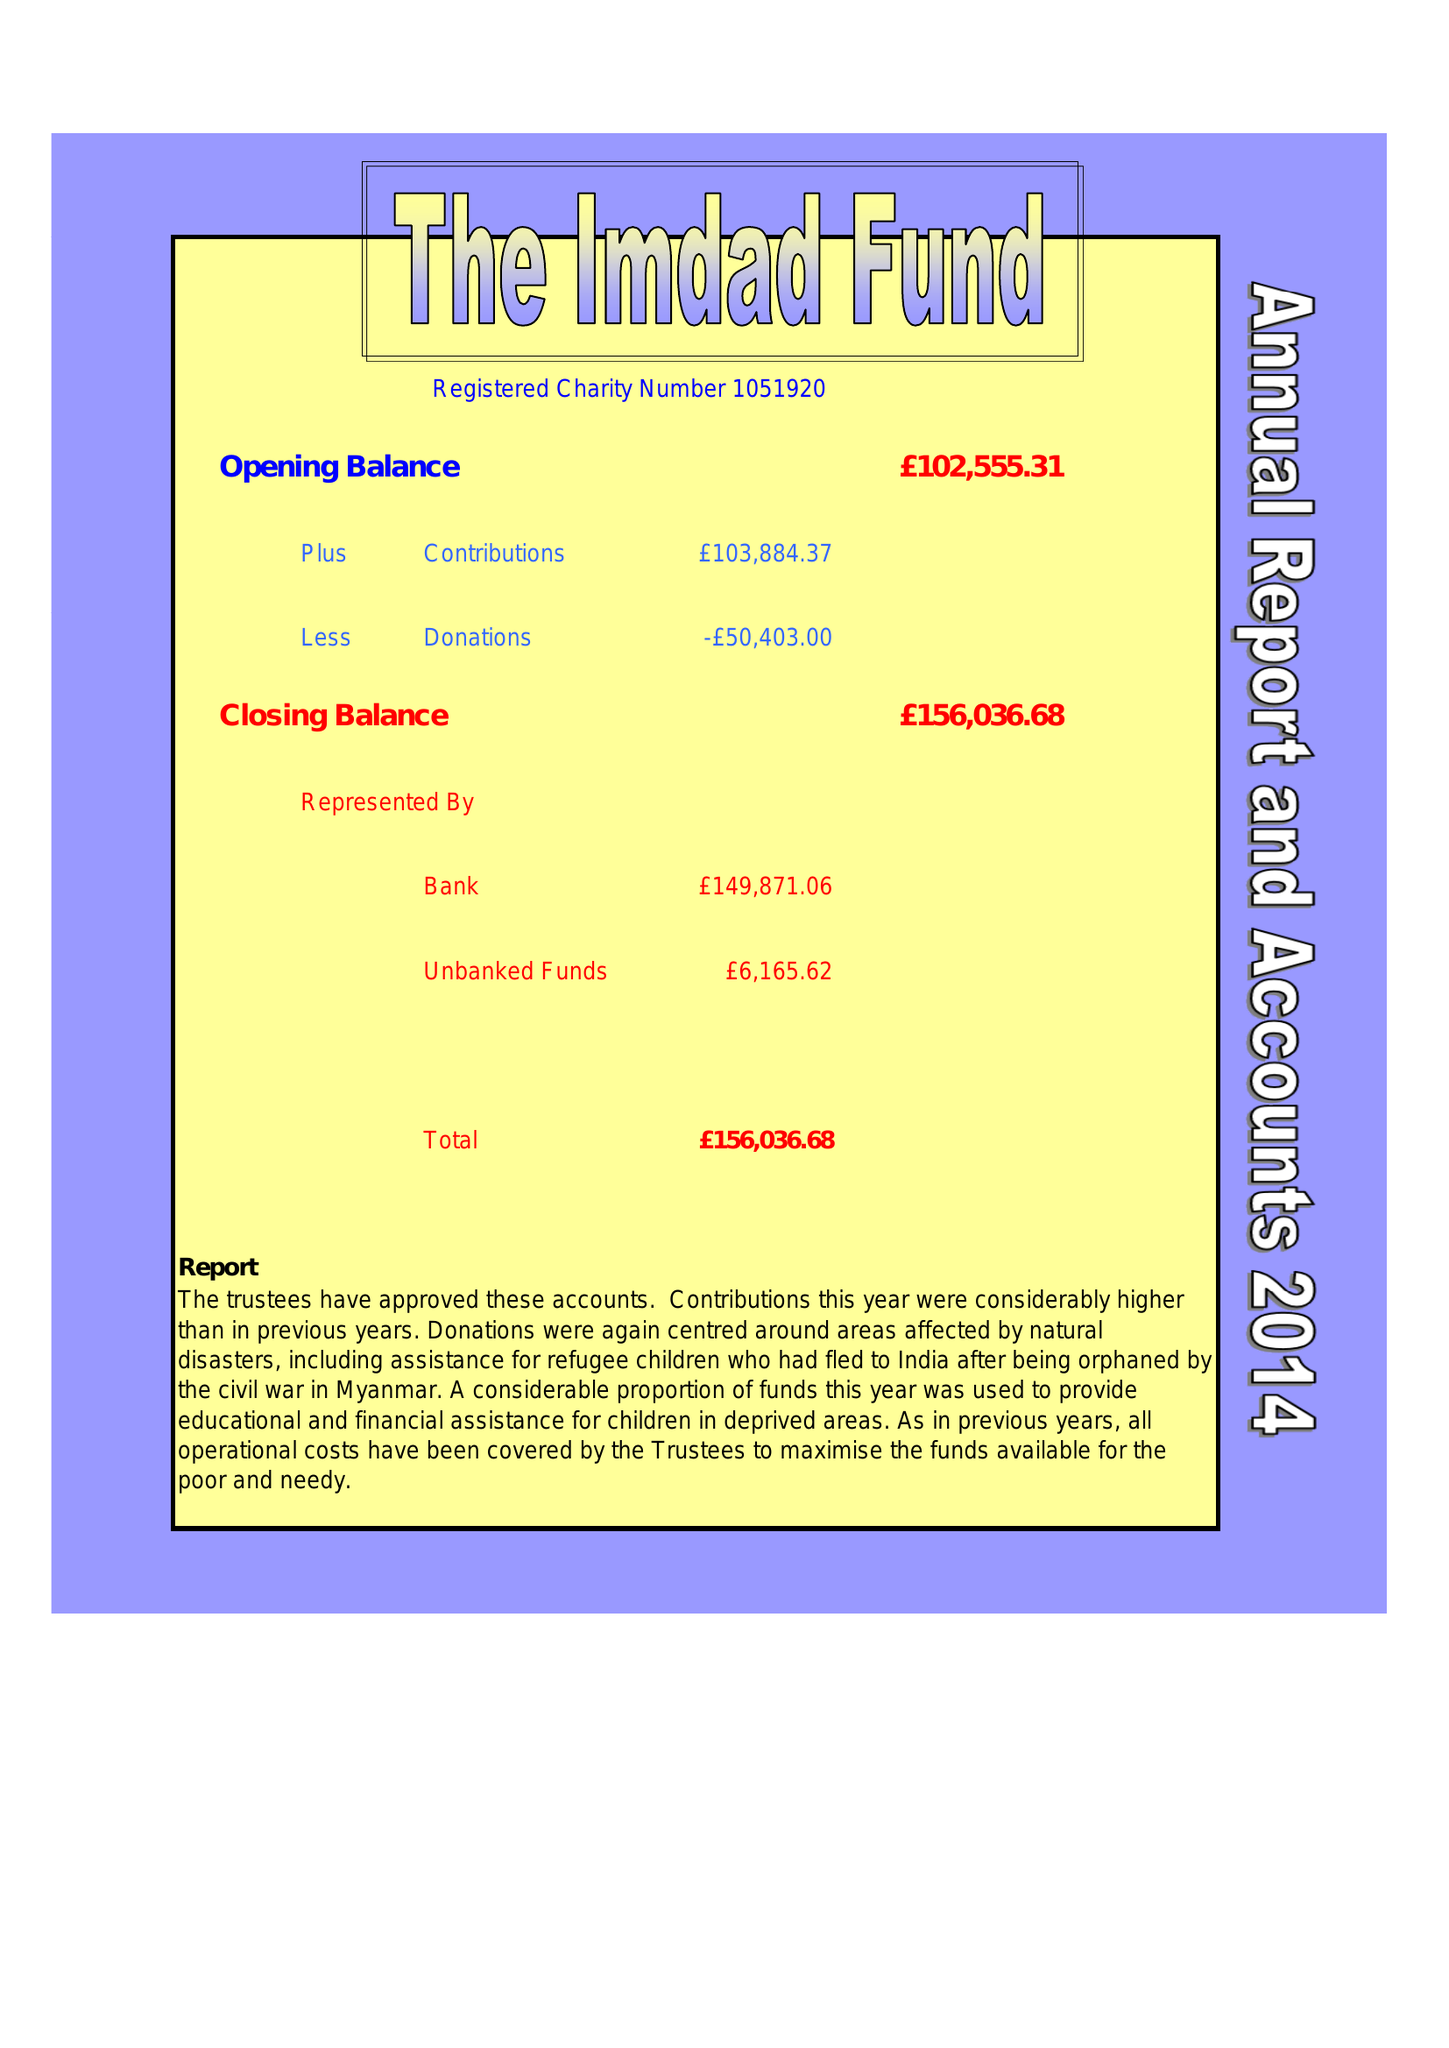What is the value for the address__street_line?
Answer the question using a single word or phrase. 190 BROWNING ROAD 